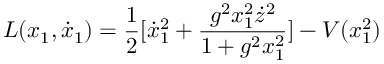<formula> <loc_0><loc_0><loc_500><loc_500>L ( x _ { 1 } , \dot { x } _ { 1 } ) = \frac { 1 } { 2 } [ \dot { x } _ { 1 } ^ { 2 } + \frac { g ^ { 2 } x _ { 1 } ^ { 2 } \dot { z } ^ { 2 } } { 1 + g ^ { 2 } x _ { 1 } ^ { 2 } } ] - V ( x _ { 1 } ^ { 2 } )</formula> 